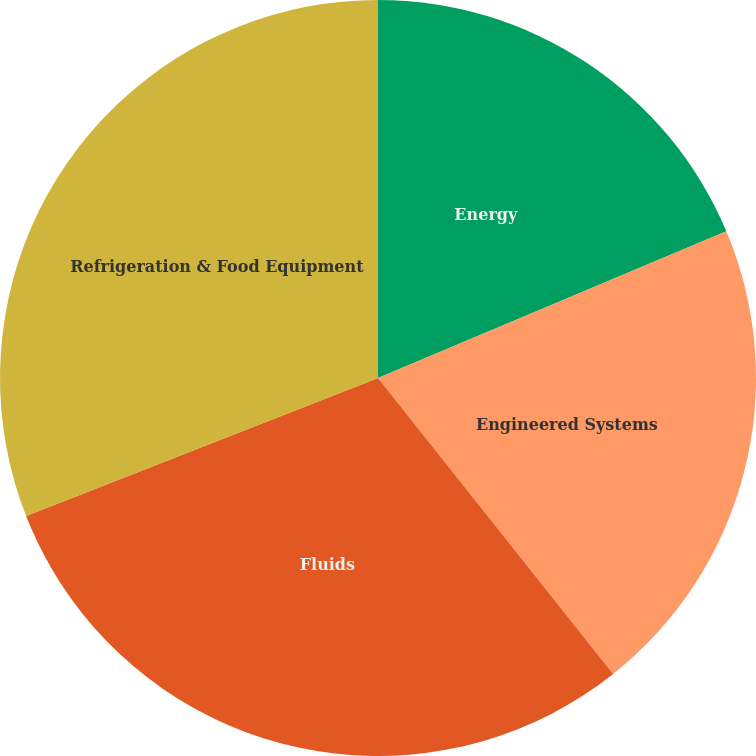Convert chart. <chart><loc_0><loc_0><loc_500><loc_500><pie_chart><fcel>Energy<fcel>Engineered Systems<fcel>Fluids<fcel>Refrigeration & Food Equipment<nl><fcel>18.65%<fcel>20.66%<fcel>29.73%<fcel>30.95%<nl></chart> 